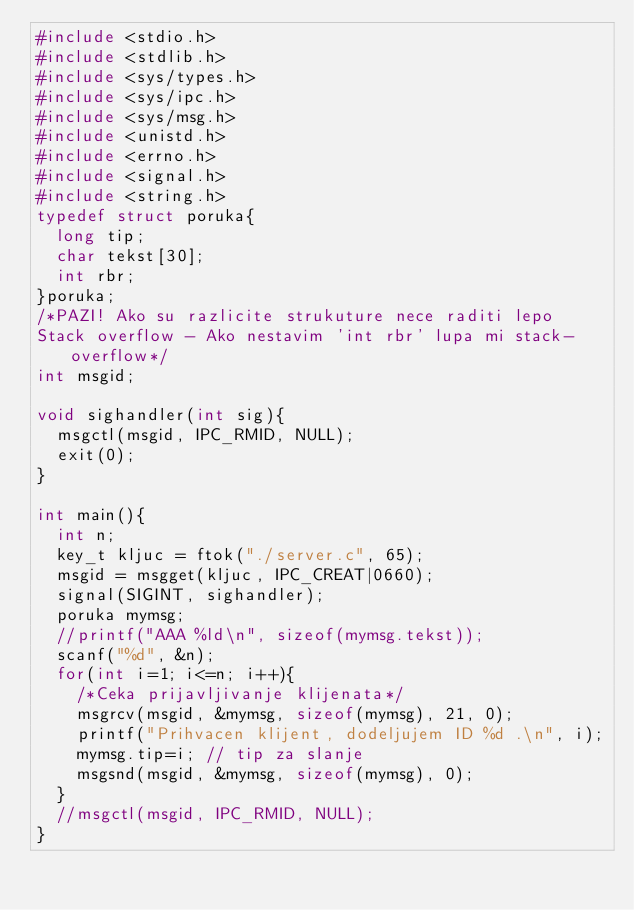Convert code to text. <code><loc_0><loc_0><loc_500><loc_500><_C_>#include <stdio.h>
#include <stdlib.h>
#include <sys/types.h>
#include <sys/ipc.h>
#include <sys/msg.h>
#include <unistd.h>
#include <errno.h>
#include <signal.h>
#include <string.h>
typedef struct poruka{	
	long tip;
	char tekst[30];
	int rbr;
}poruka;
/*PAZI! Ako su razlicite strukuture nece raditi lepo
Stack overflow - Ako nestavim 'int rbr' lupa mi stack-overflow*/
int msgid;

void sighandler(int sig){
	msgctl(msgid, IPC_RMID, NULL);
	exit(0);
}

int main(){
	int n;
	key_t kljuc = ftok("./server.c", 65);
	msgid = msgget(kljuc, IPC_CREAT|0660);
	signal(SIGINT, sighandler);
	poruka mymsg;
	//printf("AAA %ld\n", sizeof(mymsg.tekst));
	scanf("%d", &n);
	for(int i=1; i<=n; i++){
		/*Ceka prijavljivanje klijenata*/
		msgrcv(msgid, &mymsg, sizeof(mymsg), 21, 0);
		printf("Prihvacen klijent, dodeljujem ID %d .\n", i);
		mymsg.tip=i; // tip za slanje
		msgsnd(msgid, &mymsg, sizeof(mymsg), 0);
	}
	//msgctl(msgid, IPC_RMID, NULL);
}
</code> 